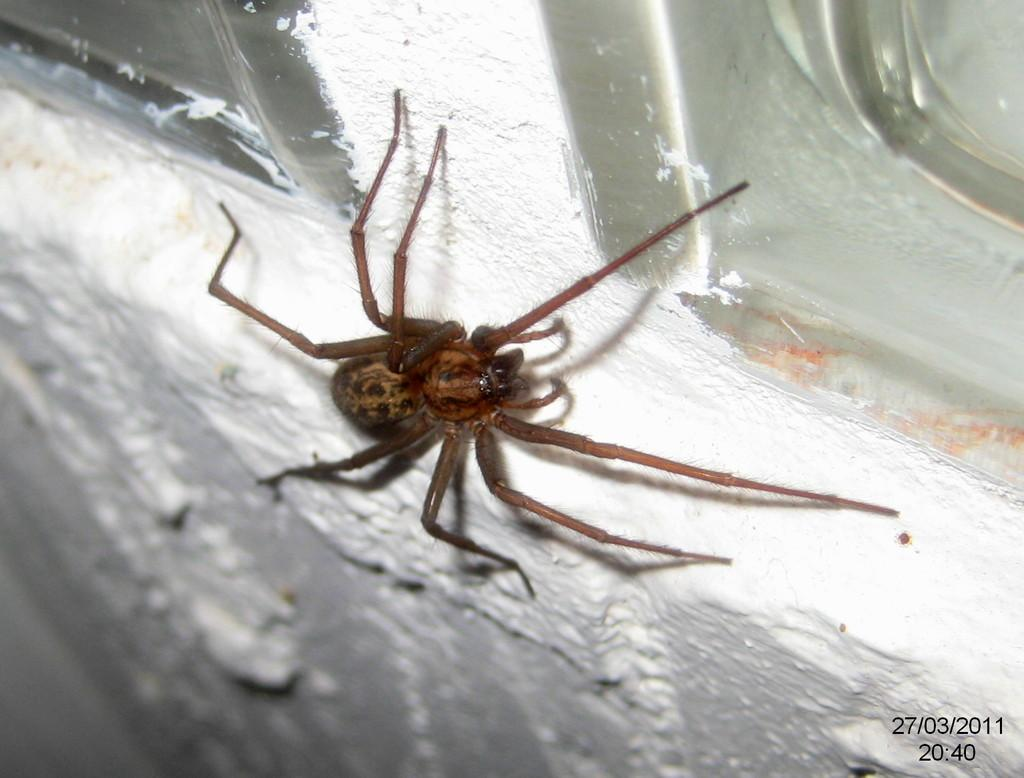What type of animal is in the image? There is a wolf spider in the image. What is the color of the surface the wolf spider is on? The wolf spider is on a white surface. How many pigs are playing volleyball in the image? There are no pigs or volleyball in the image; it features a wolf spider on a white surface. 